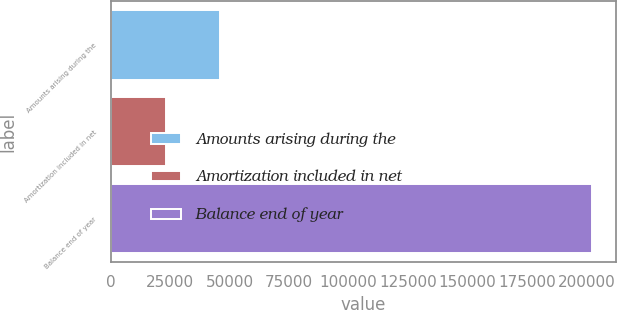Convert chart. <chart><loc_0><loc_0><loc_500><loc_500><bar_chart><fcel>Amounts arising during the<fcel>Amortization included in net<fcel>Balance end of year<nl><fcel>45804<fcel>23313<fcel>202292<nl></chart> 